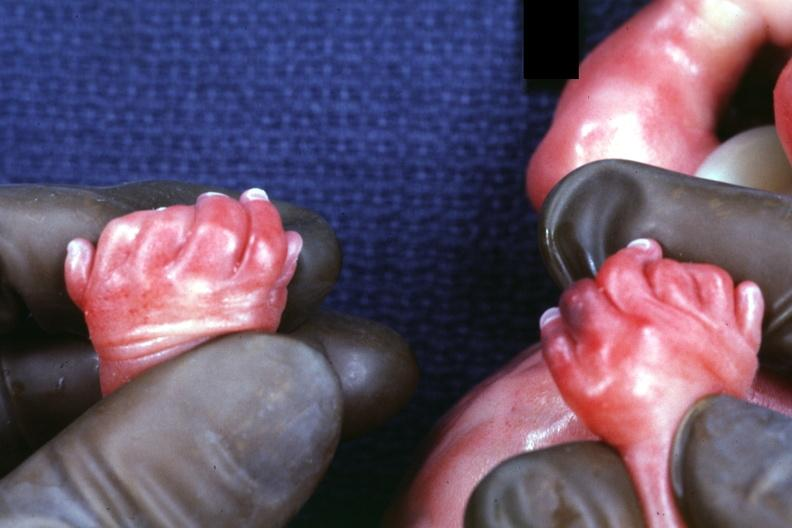what is present?
Answer the question using a single word or phrase. Hand 